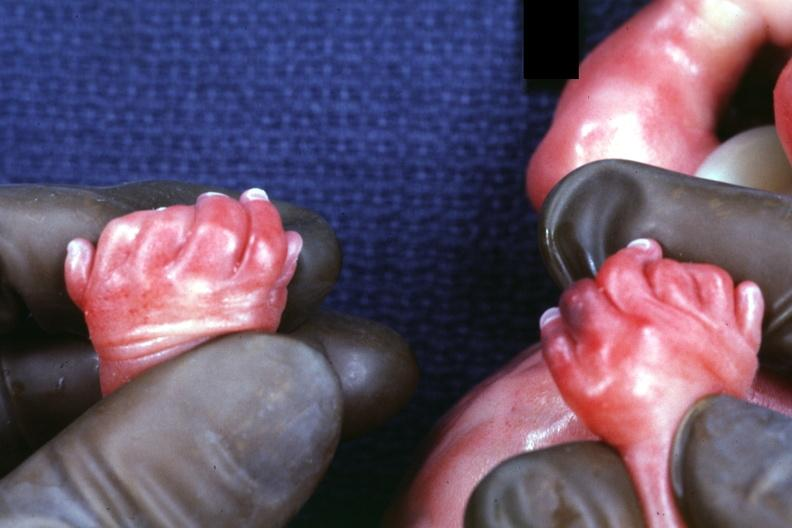what is present?
Answer the question using a single word or phrase. Hand 